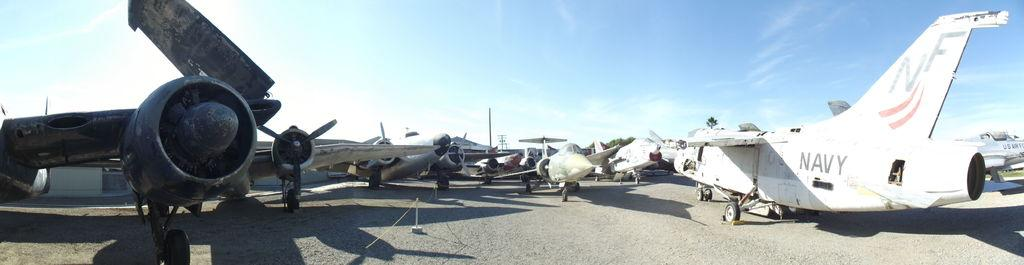<image>
Share a concise interpretation of the image provided. A white Navy plane in a yard with other planes. 